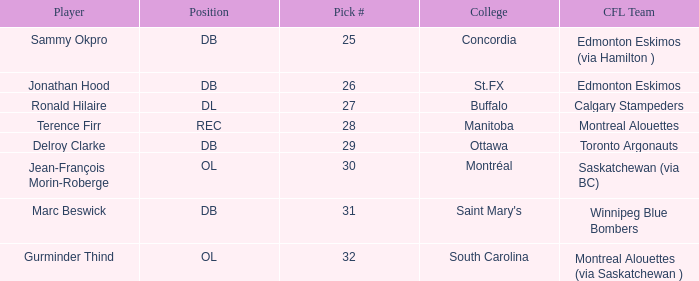Which College has a Pick # larger than 30, and a Position of ol? South Carolina. 